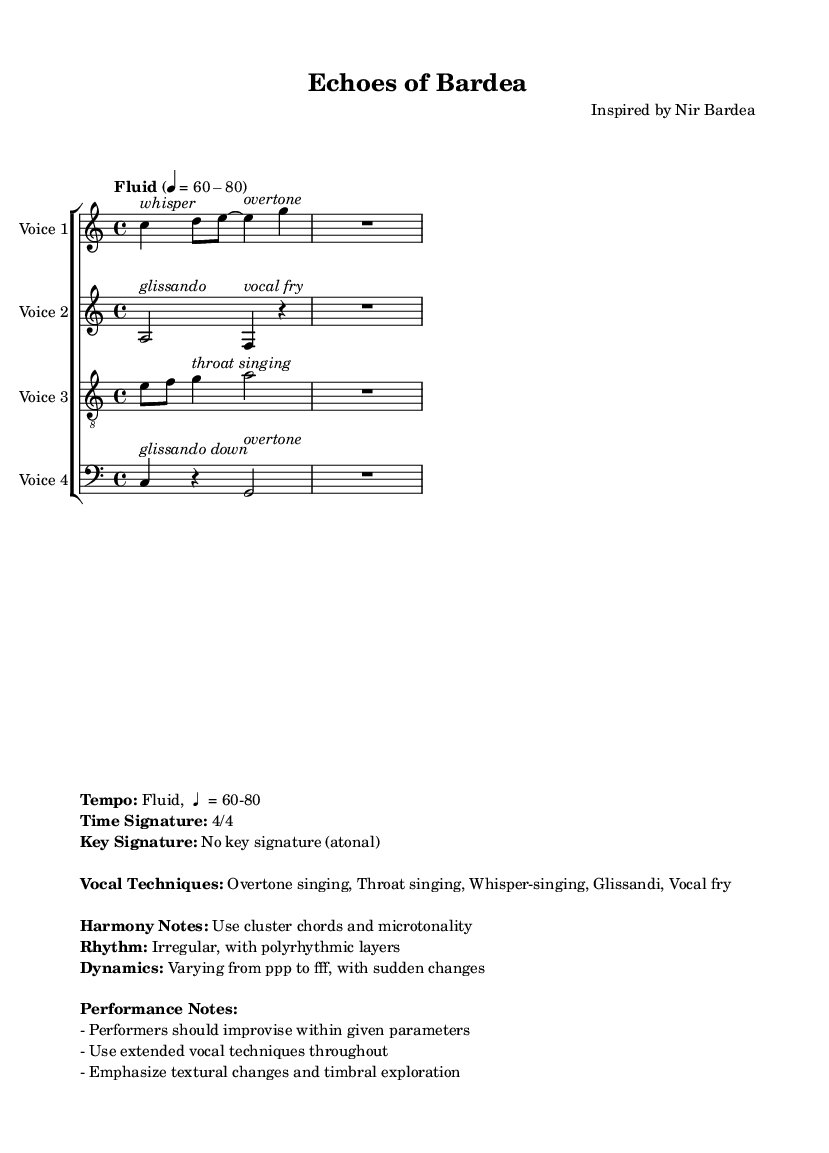What is the time signature of this music? The time signature is indicated at the beginning of the sheet music, showing how many beats per measure. The notation 4/4 signifies that there are four beats in each measure.
Answer: 4/4 What is the tempo marking in this piece? The tempo is indicated as "Fluid," with a specification of 60-80 beats per minute. This means the piece should be performed at a flexible speed within this range.
Answer: Fluid, 60-80 What vocal technique is used by the Soprano? The Soprano part indicates the vocal technique "whisper," noted in italics above the first note. This technique specifies that the singer should perform softly, using breathy sounds.
Answer: whisper How many vocal parts are present in this composition? The sheet music contains a total of four distinct vocal parts: Soprano, Alto, Tenor, and Bass. Each part is clearly labeled, providing the musicians with their respective vocal range.
Answer: Four What is the primary characteristic of the key signature in this piece? The sheet music indicates that there is no key signature, which means the piece is atonal. This allows for greater freedom in melody and harmony without being tied to traditional tonal structures.
Answer: No key signature (atonal) What dynamics vary within the piece? The dynamics indicated expand from very soft (ppp) to very loud (fff), with suggestions for sudden changes. This variance adds to the piece’s emotional depth and creates a dynamic textural experience for both performers and listeners.
Answer: Varying from ppp to fff What type of harmonies should be used? The instruction states to use cluster chords and microtonality, which reflects the experimental nature of the composition. This approach provides a rich and complex harmonic texture that is characteristic of experimental music.
Answer: Cluster chords and microtonality 